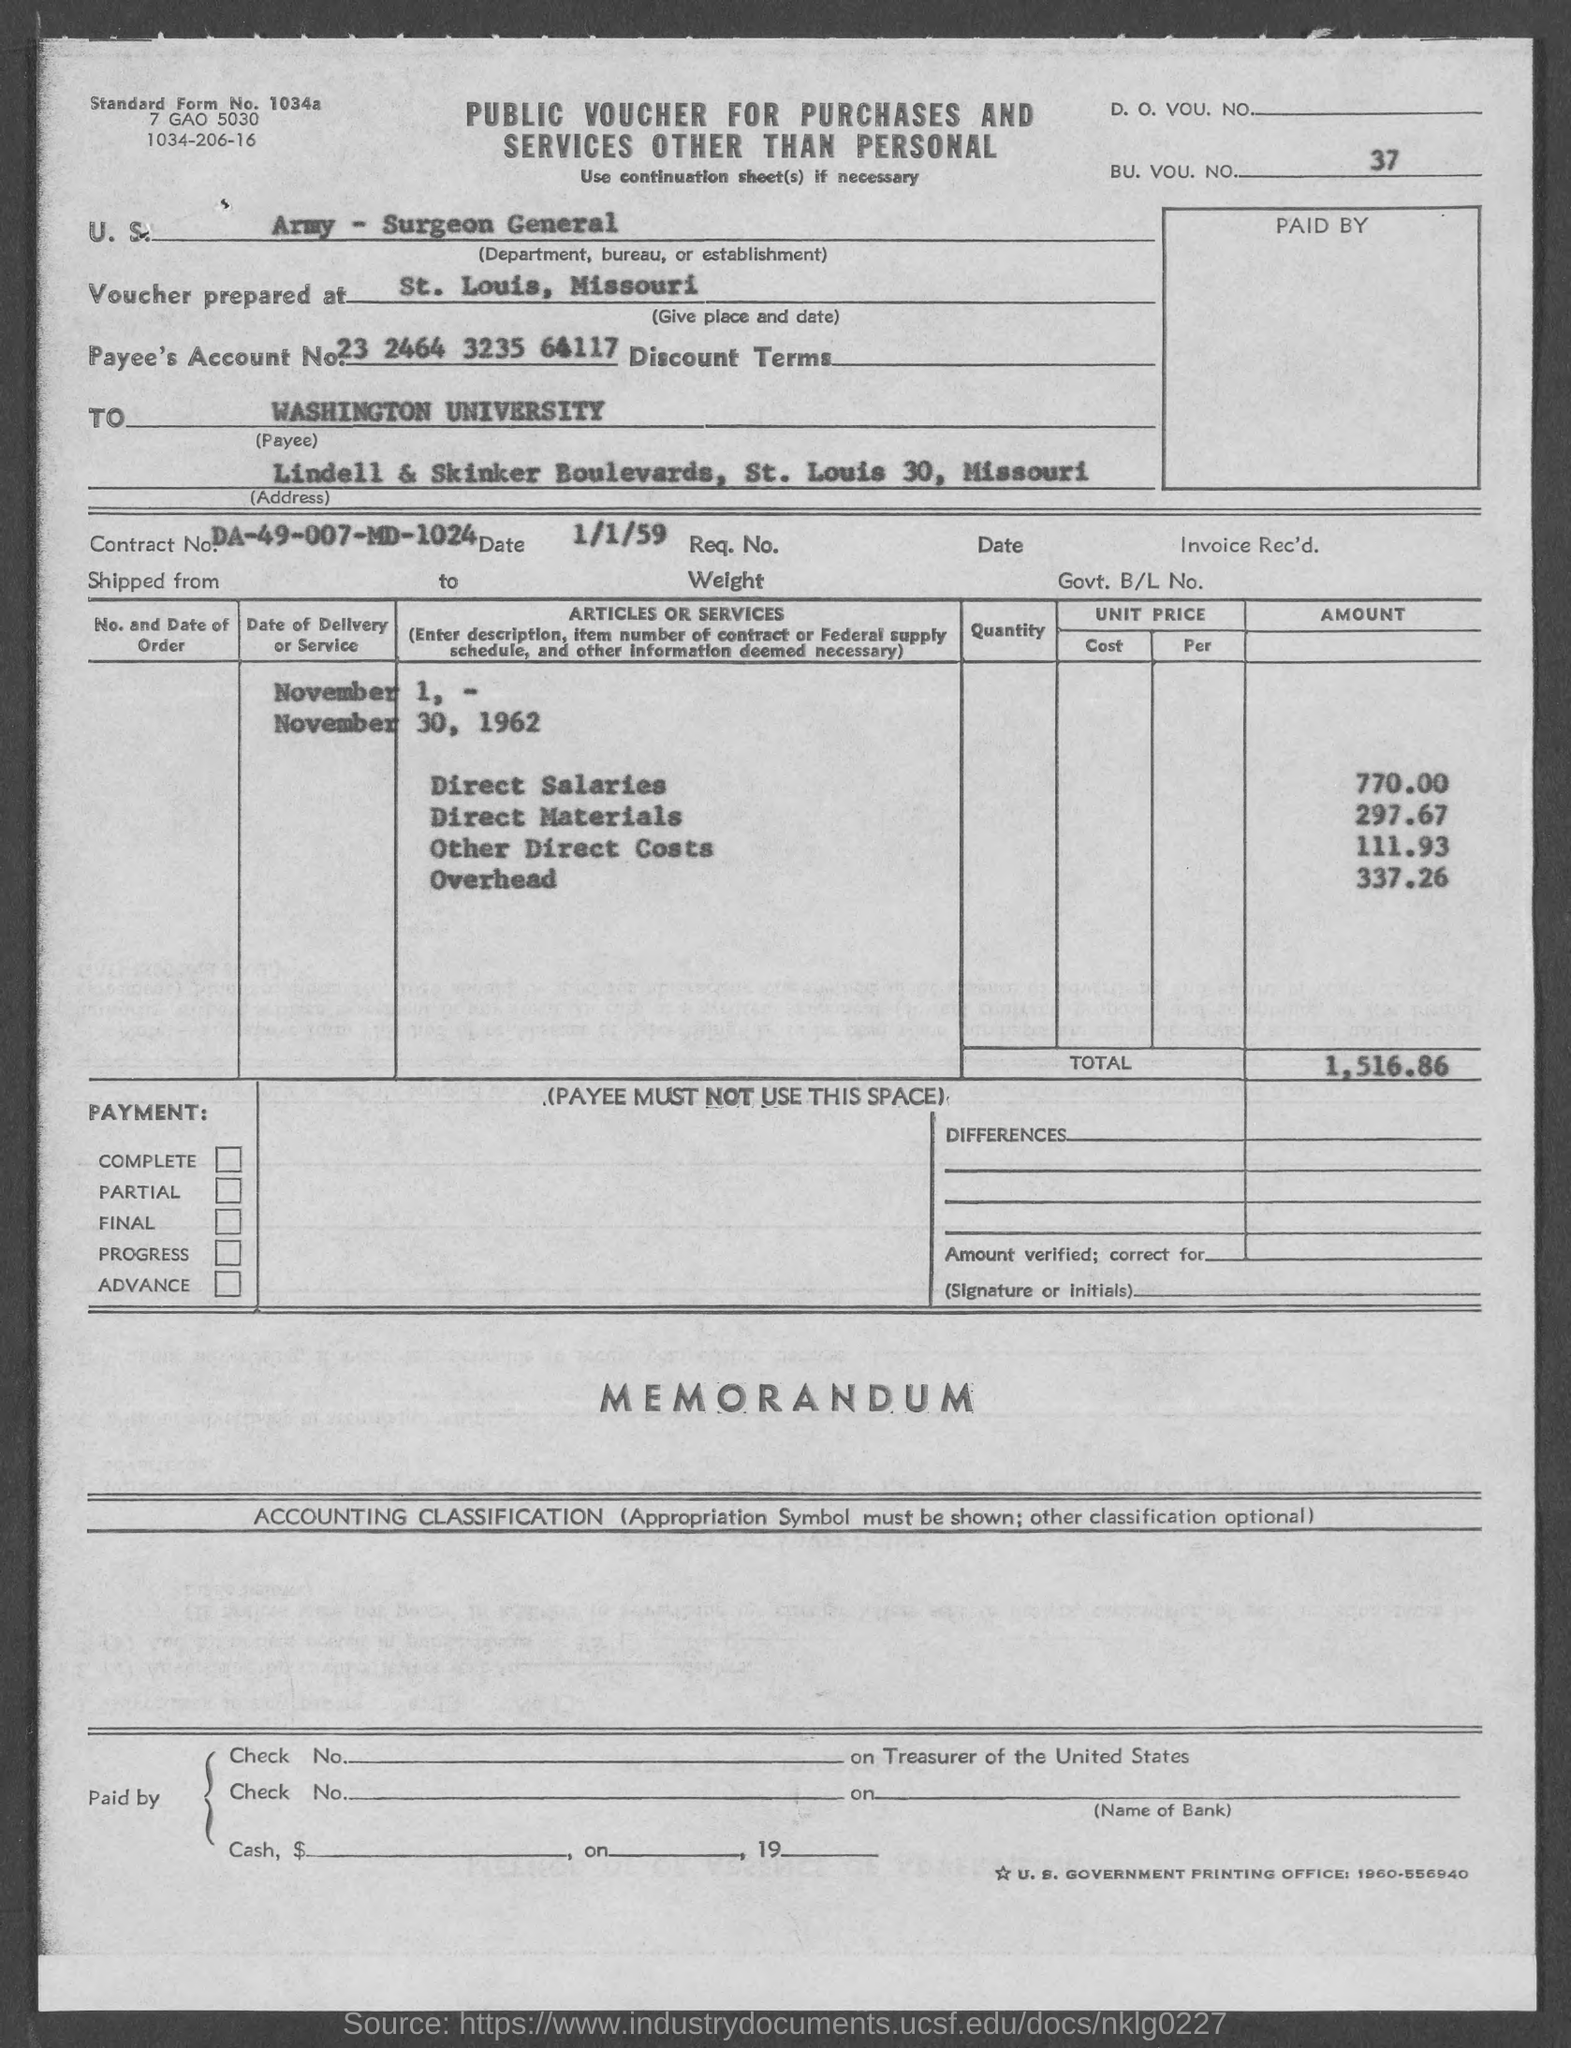Outline some significant characteristics in this image. The amount of direct materials mentioned in the given page is 297.67. The total amount mentioned in the given form is 1,516.86 dollars. The direct salaries mentioned in the given form are 770.00. The payee's account number mentioned in the given form is 23 2464 3235 64117. What is the date mentioned on the given page? It is January 1, 1959. 